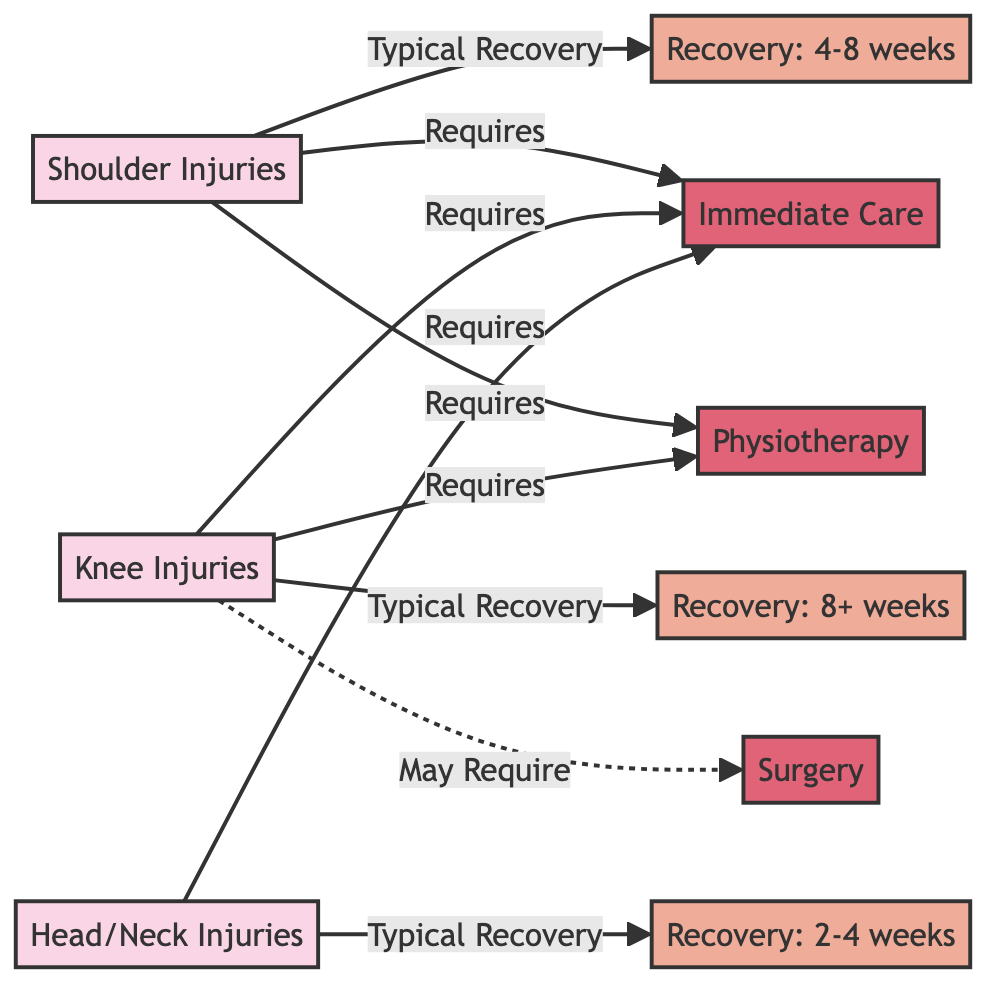What are the shoulder injuries categorized as? In the diagram, "Shoulder Injuries" is explicitly labeled as a type of injury.
Answer: Shoulder Injuries What is the typical recovery time for knee injuries? The diagram indicates that knee injuries typically lead to a recovery period categorized as "Recovery: 8+ weeks."
Answer: 8+ weeks Which treatment is required for head injuries? According to the diagram, head injuries require "Immediate Care," as indicated by the directed edge from head injuries to immediate care.
Answer: Immediate Care How many types of injuries are indicated in the diagram? The diagram lists three types of injuries: shoulder, knee, and head/neck injuries, so the count of injury types is three.
Answer: 3 What is the recovery period for shoulder injuries? The diagram shows that shoulder injuries typically lead to a recovery period described as "Recovery: 4-8 weeks."
Answer: 4-8 weeks What type of care is specifically mentioned for knee injuries? The diagram states that knee injuries require "Immediate Care" and "Physiotherapy," but "Immediate Care" is specifically highlighted with a direct flow.
Answer: Immediate Care What is the relationship between surgery and knee injuries? The diagram shows a dotted or non-solid line indicating that "Surgery" may be required for knee injuries, suggesting a conditional or less frequent association.
Answer: May Require How many treatment types are in the diagram? There are three treatment types listed: Immediate Care, Physiotherapy, and Surgery, so the total number of treatment types is three.
Answer: 3 What type of recovery period is associated with head injuries? The diagram categorizes head injuries with a recovery period labeled as "Recovery: 2-4 weeks."
Answer: 2-4 weeks 